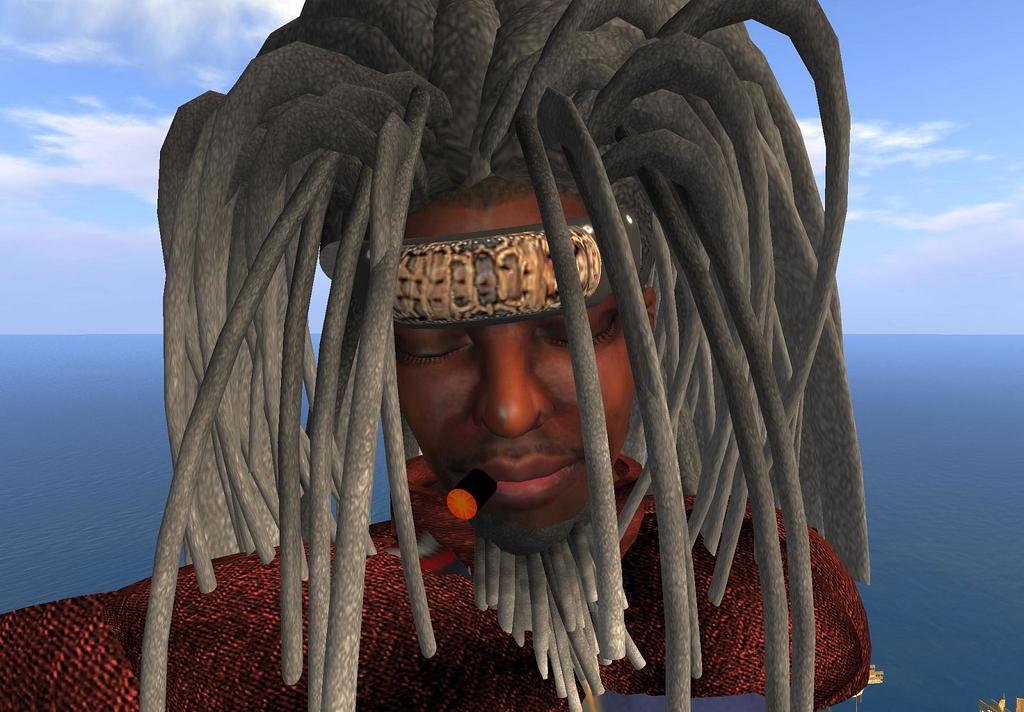Describe this image in one or two sentences. It is the animated image in which there is a man who is having a cigar in his mouth and a long hair on his head. 